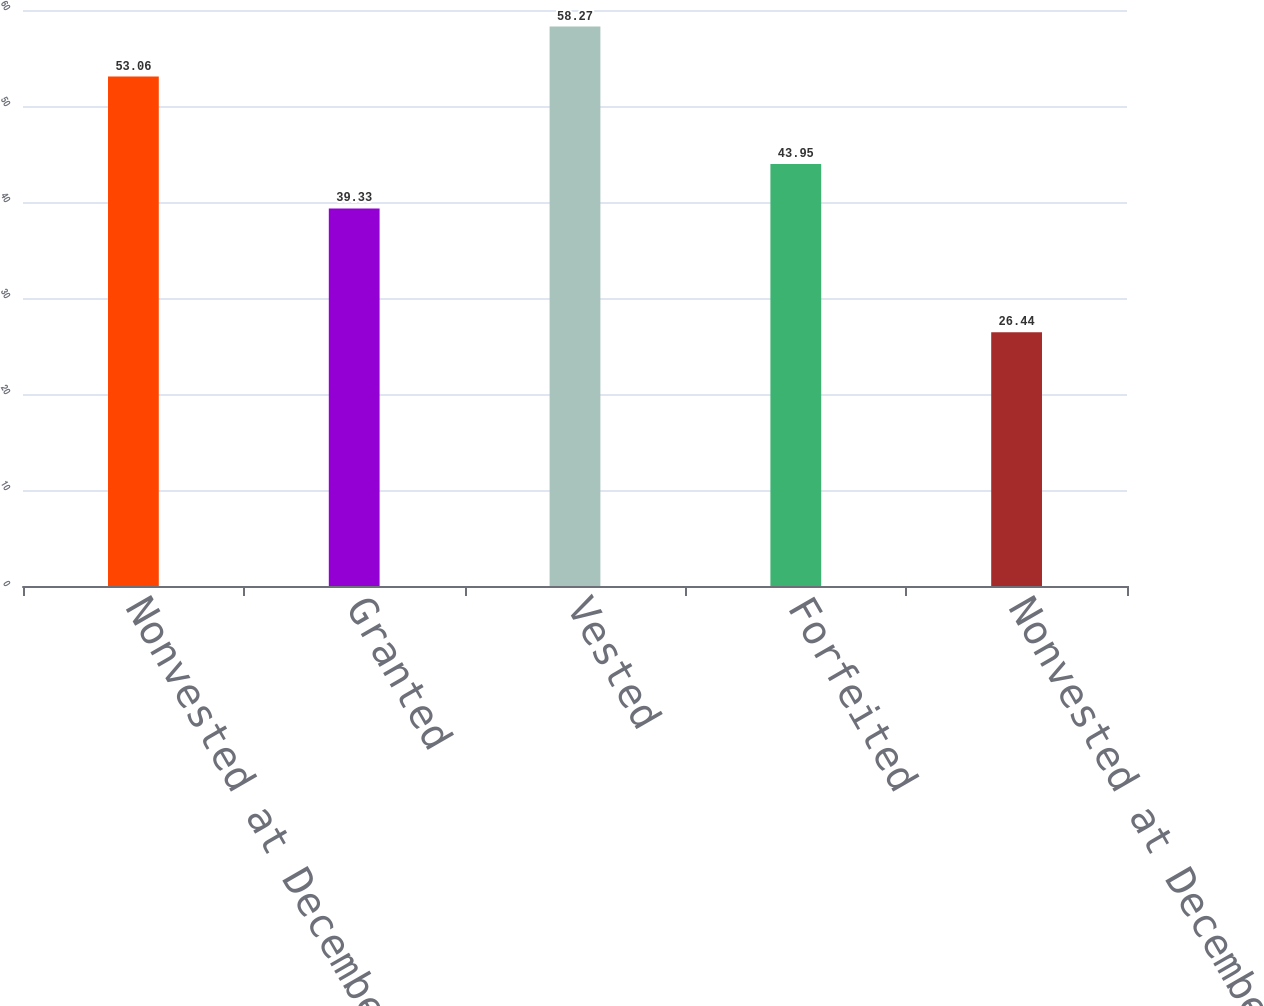Convert chart to OTSL. <chart><loc_0><loc_0><loc_500><loc_500><bar_chart><fcel>Nonvested at December 31 2009<fcel>Granted<fcel>Vested<fcel>Forfeited<fcel>Nonvested at December 31 2010<nl><fcel>53.06<fcel>39.33<fcel>58.27<fcel>43.95<fcel>26.44<nl></chart> 